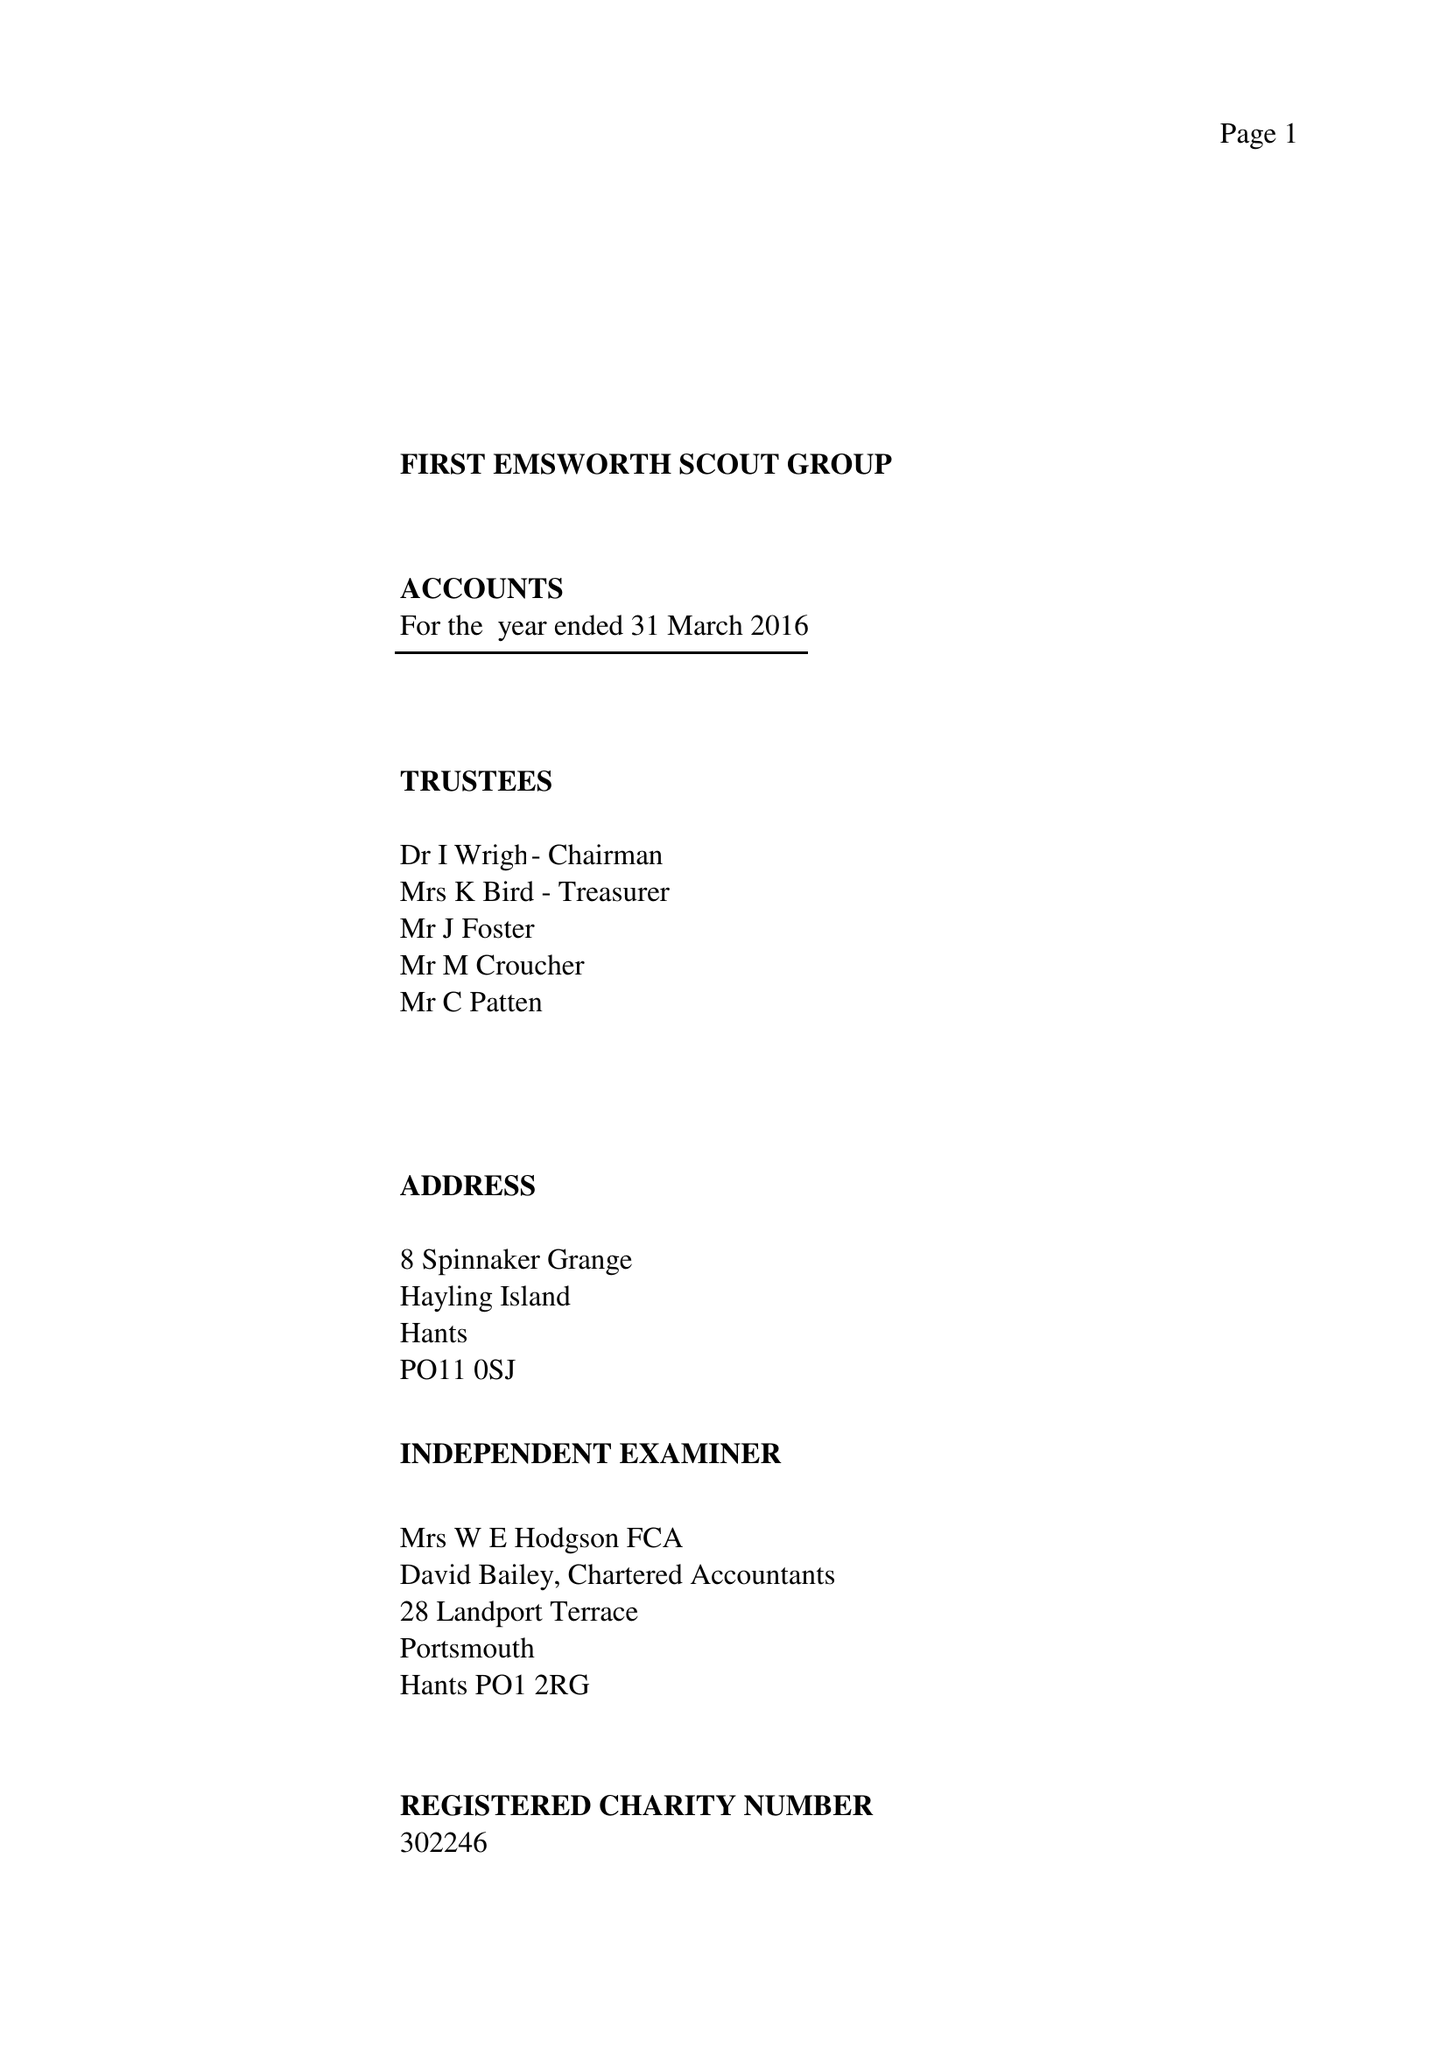What is the value for the report_date?
Answer the question using a single word or phrase. 2016-03-31 